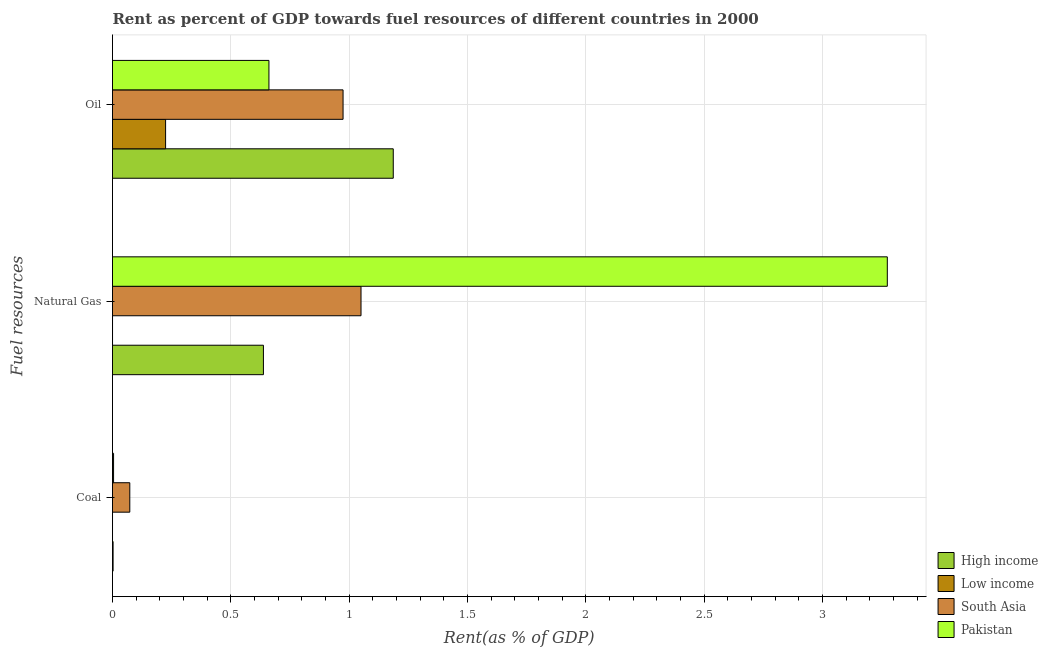How many groups of bars are there?
Your answer should be very brief. 3. Are the number of bars on each tick of the Y-axis equal?
Provide a short and direct response. Yes. How many bars are there on the 1st tick from the top?
Make the answer very short. 4. How many bars are there on the 3rd tick from the bottom?
Provide a succinct answer. 4. What is the label of the 3rd group of bars from the top?
Ensure brevity in your answer.  Coal. What is the rent towards oil in Low income?
Make the answer very short. 0.22. Across all countries, what is the maximum rent towards oil?
Make the answer very short. 1.19. Across all countries, what is the minimum rent towards natural gas?
Offer a very short reply. 0. In which country was the rent towards natural gas minimum?
Ensure brevity in your answer.  Low income. What is the total rent towards natural gas in the graph?
Your response must be concise. 4.96. What is the difference between the rent towards natural gas in Pakistan and that in High income?
Keep it short and to the point. 2.64. What is the difference between the rent towards coal in South Asia and the rent towards oil in Pakistan?
Your response must be concise. -0.59. What is the average rent towards oil per country?
Provide a succinct answer. 0.76. What is the difference between the rent towards coal and rent towards oil in Pakistan?
Offer a very short reply. -0.66. What is the ratio of the rent towards oil in High income to that in Pakistan?
Provide a succinct answer. 1.79. Is the rent towards oil in Pakistan less than that in Low income?
Offer a terse response. No. Is the difference between the rent towards oil in Pakistan and Low income greater than the difference between the rent towards coal in Pakistan and Low income?
Offer a terse response. Yes. What is the difference between the highest and the second highest rent towards coal?
Ensure brevity in your answer.  0.07. What is the difference between the highest and the lowest rent towards natural gas?
Your answer should be compact. 3.27. In how many countries, is the rent towards oil greater than the average rent towards oil taken over all countries?
Provide a succinct answer. 2. Is the sum of the rent towards oil in High income and Low income greater than the maximum rent towards coal across all countries?
Make the answer very short. Yes. What does the 3rd bar from the top in Coal represents?
Your response must be concise. Low income. What does the 3rd bar from the bottom in Oil represents?
Make the answer very short. South Asia. Is it the case that in every country, the sum of the rent towards coal and rent towards natural gas is greater than the rent towards oil?
Provide a short and direct response. No. Are all the bars in the graph horizontal?
Your response must be concise. Yes. Does the graph contain grids?
Make the answer very short. Yes. What is the title of the graph?
Offer a terse response. Rent as percent of GDP towards fuel resources of different countries in 2000. Does "Equatorial Guinea" appear as one of the legend labels in the graph?
Your response must be concise. No. What is the label or title of the X-axis?
Offer a terse response. Rent(as % of GDP). What is the label or title of the Y-axis?
Your response must be concise. Fuel resources. What is the Rent(as % of GDP) of High income in Coal?
Give a very brief answer. 0. What is the Rent(as % of GDP) of Low income in Coal?
Make the answer very short. 3.43081541094935e-5. What is the Rent(as % of GDP) of South Asia in Coal?
Ensure brevity in your answer.  0.07. What is the Rent(as % of GDP) in Pakistan in Coal?
Make the answer very short. 0. What is the Rent(as % of GDP) of High income in Natural Gas?
Your answer should be compact. 0.64. What is the Rent(as % of GDP) of Low income in Natural Gas?
Provide a short and direct response. 0. What is the Rent(as % of GDP) in South Asia in Natural Gas?
Give a very brief answer. 1.05. What is the Rent(as % of GDP) of Pakistan in Natural Gas?
Offer a very short reply. 3.27. What is the Rent(as % of GDP) in High income in Oil?
Your response must be concise. 1.19. What is the Rent(as % of GDP) of Low income in Oil?
Your answer should be very brief. 0.22. What is the Rent(as % of GDP) of South Asia in Oil?
Provide a succinct answer. 0.97. What is the Rent(as % of GDP) of Pakistan in Oil?
Provide a succinct answer. 0.66. Across all Fuel resources, what is the maximum Rent(as % of GDP) of High income?
Provide a succinct answer. 1.19. Across all Fuel resources, what is the maximum Rent(as % of GDP) of Low income?
Offer a terse response. 0.22. Across all Fuel resources, what is the maximum Rent(as % of GDP) in South Asia?
Offer a terse response. 1.05. Across all Fuel resources, what is the maximum Rent(as % of GDP) in Pakistan?
Ensure brevity in your answer.  3.27. Across all Fuel resources, what is the minimum Rent(as % of GDP) of High income?
Keep it short and to the point. 0. Across all Fuel resources, what is the minimum Rent(as % of GDP) of Low income?
Keep it short and to the point. 3.43081541094935e-5. Across all Fuel resources, what is the minimum Rent(as % of GDP) in South Asia?
Give a very brief answer. 0.07. Across all Fuel resources, what is the minimum Rent(as % of GDP) in Pakistan?
Ensure brevity in your answer.  0. What is the total Rent(as % of GDP) in High income in the graph?
Offer a very short reply. 1.83. What is the total Rent(as % of GDP) of Low income in the graph?
Provide a short and direct response. 0.22. What is the total Rent(as % of GDP) of South Asia in the graph?
Your response must be concise. 2.1. What is the total Rent(as % of GDP) in Pakistan in the graph?
Ensure brevity in your answer.  3.94. What is the difference between the Rent(as % of GDP) of High income in Coal and that in Natural Gas?
Your response must be concise. -0.64. What is the difference between the Rent(as % of GDP) in Low income in Coal and that in Natural Gas?
Give a very brief answer. -0. What is the difference between the Rent(as % of GDP) in South Asia in Coal and that in Natural Gas?
Offer a terse response. -0.98. What is the difference between the Rent(as % of GDP) in Pakistan in Coal and that in Natural Gas?
Your answer should be very brief. -3.27. What is the difference between the Rent(as % of GDP) of High income in Coal and that in Oil?
Make the answer very short. -1.18. What is the difference between the Rent(as % of GDP) of Low income in Coal and that in Oil?
Offer a very short reply. -0.22. What is the difference between the Rent(as % of GDP) of South Asia in Coal and that in Oil?
Give a very brief answer. -0.9. What is the difference between the Rent(as % of GDP) in Pakistan in Coal and that in Oil?
Your answer should be compact. -0.66. What is the difference between the Rent(as % of GDP) of High income in Natural Gas and that in Oil?
Give a very brief answer. -0.55. What is the difference between the Rent(as % of GDP) in Low income in Natural Gas and that in Oil?
Provide a succinct answer. -0.22. What is the difference between the Rent(as % of GDP) in South Asia in Natural Gas and that in Oil?
Provide a short and direct response. 0.08. What is the difference between the Rent(as % of GDP) in Pakistan in Natural Gas and that in Oil?
Give a very brief answer. 2.61. What is the difference between the Rent(as % of GDP) in High income in Coal and the Rent(as % of GDP) in Low income in Natural Gas?
Your answer should be compact. 0. What is the difference between the Rent(as % of GDP) of High income in Coal and the Rent(as % of GDP) of South Asia in Natural Gas?
Your answer should be compact. -1.05. What is the difference between the Rent(as % of GDP) of High income in Coal and the Rent(as % of GDP) of Pakistan in Natural Gas?
Make the answer very short. -3.27. What is the difference between the Rent(as % of GDP) in Low income in Coal and the Rent(as % of GDP) in South Asia in Natural Gas?
Give a very brief answer. -1.05. What is the difference between the Rent(as % of GDP) of Low income in Coal and the Rent(as % of GDP) of Pakistan in Natural Gas?
Offer a very short reply. -3.27. What is the difference between the Rent(as % of GDP) in South Asia in Coal and the Rent(as % of GDP) in Pakistan in Natural Gas?
Make the answer very short. -3.2. What is the difference between the Rent(as % of GDP) of High income in Coal and the Rent(as % of GDP) of Low income in Oil?
Your answer should be very brief. -0.22. What is the difference between the Rent(as % of GDP) in High income in Coal and the Rent(as % of GDP) in South Asia in Oil?
Make the answer very short. -0.97. What is the difference between the Rent(as % of GDP) in High income in Coal and the Rent(as % of GDP) in Pakistan in Oil?
Offer a very short reply. -0.66. What is the difference between the Rent(as % of GDP) in Low income in Coal and the Rent(as % of GDP) in South Asia in Oil?
Offer a terse response. -0.97. What is the difference between the Rent(as % of GDP) in Low income in Coal and the Rent(as % of GDP) in Pakistan in Oil?
Your answer should be very brief. -0.66. What is the difference between the Rent(as % of GDP) of South Asia in Coal and the Rent(as % of GDP) of Pakistan in Oil?
Provide a succinct answer. -0.59. What is the difference between the Rent(as % of GDP) of High income in Natural Gas and the Rent(as % of GDP) of Low income in Oil?
Your answer should be very brief. 0.41. What is the difference between the Rent(as % of GDP) of High income in Natural Gas and the Rent(as % of GDP) of South Asia in Oil?
Your response must be concise. -0.34. What is the difference between the Rent(as % of GDP) in High income in Natural Gas and the Rent(as % of GDP) in Pakistan in Oil?
Provide a short and direct response. -0.02. What is the difference between the Rent(as % of GDP) in Low income in Natural Gas and the Rent(as % of GDP) in South Asia in Oil?
Your answer should be very brief. -0.97. What is the difference between the Rent(as % of GDP) in Low income in Natural Gas and the Rent(as % of GDP) in Pakistan in Oil?
Offer a very short reply. -0.66. What is the difference between the Rent(as % of GDP) of South Asia in Natural Gas and the Rent(as % of GDP) of Pakistan in Oil?
Provide a succinct answer. 0.39. What is the average Rent(as % of GDP) of High income per Fuel resources?
Offer a very short reply. 0.61. What is the average Rent(as % of GDP) of Low income per Fuel resources?
Provide a short and direct response. 0.07. What is the average Rent(as % of GDP) in South Asia per Fuel resources?
Give a very brief answer. 0.7. What is the average Rent(as % of GDP) in Pakistan per Fuel resources?
Make the answer very short. 1.31. What is the difference between the Rent(as % of GDP) in High income and Rent(as % of GDP) in Low income in Coal?
Offer a terse response. 0. What is the difference between the Rent(as % of GDP) in High income and Rent(as % of GDP) in South Asia in Coal?
Your response must be concise. -0.07. What is the difference between the Rent(as % of GDP) of High income and Rent(as % of GDP) of Pakistan in Coal?
Offer a terse response. -0. What is the difference between the Rent(as % of GDP) in Low income and Rent(as % of GDP) in South Asia in Coal?
Make the answer very short. -0.07. What is the difference between the Rent(as % of GDP) of Low income and Rent(as % of GDP) of Pakistan in Coal?
Your answer should be very brief. -0. What is the difference between the Rent(as % of GDP) of South Asia and Rent(as % of GDP) of Pakistan in Coal?
Give a very brief answer. 0.07. What is the difference between the Rent(as % of GDP) in High income and Rent(as % of GDP) in Low income in Natural Gas?
Provide a succinct answer. 0.64. What is the difference between the Rent(as % of GDP) of High income and Rent(as % of GDP) of South Asia in Natural Gas?
Ensure brevity in your answer.  -0.41. What is the difference between the Rent(as % of GDP) of High income and Rent(as % of GDP) of Pakistan in Natural Gas?
Your answer should be compact. -2.64. What is the difference between the Rent(as % of GDP) of Low income and Rent(as % of GDP) of South Asia in Natural Gas?
Keep it short and to the point. -1.05. What is the difference between the Rent(as % of GDP) in Low income and Rent(as % of GDP) in Pakistan in Natural Gas?
Keep it short and to the point. -3.27. What is the difference between the Rent(as % of GDP) of South Asia and Rent(as % of GDP) of Pakistan in Natural Gas?
Give a very brief answer. -2.22. What is the difference between the Rent(as % of GDP) in High income and Rent(as % of GDP) in Low income in Oil?
Offer a terse response. 0.96. What is the difference between the Rent(as % of GDP) in High income and Rent(as % of GDP) in South Asia in Oil?
Ensure brevity in your answer.  0.21. What is the difference between the Rent(as % of GDP) of High income and Rent(as % of GDP) of Pakistan in Oil?
Make the answer very short. 0.53. What is the difference between the Rent(as % of GDP) in Low income and Rent(as % of GDP) in South Asia in Oil?
Provide a short and direct response. -0.75. What is the difference between the Rent(as % of GDP) of Low income and Rent(as % of GDP) of Pakistan in Oil?
Your response must be concise. -0.44. What is the difference between the Rent(as % of GDP) in South Asia and Rent(as % of GDP) in Pakistan in Oil?
Keep it short and to the point. 0.31. What is the ratio of the Rent(as % of GDP) in High income in Coal to that in Natural Gas?
Give a very brief answer. 0. What is the ratio of the Rent(as % of GDP) of Low income in Coal to that in Natural Gas?
Provide a short and direct response. 0.23. What is the ratio of the Rent(as % of GDP) of South Asia in Coal to that in Natural Gas?
Your answer should be very brief. 0.07. What is the ratio of the Rent(as % of GDP) in Pakistan in Coal to that in Natural Gas?
Provide a short and direct response. 0. What is the ratio of the Rent(as % of GDP) of High income in Coal to that in Oil?
Your response must be concise. 0. What is the ratio of the Rent(as % of GDP) of Low income in Coal to that in Oil?
Your answer should be very brief. 0. What is the ratio of the Rent(as % of GDP) in South Asia in Coal to that in Oil?
Provide a succinct answer. 0.07. What is the ratio of the Rent(as % of GDP) of Pakistan in Coal to that in Oil?
Your answer should be compact. 0.01. What is the ratio of the Rent(as % of GDP) of High income in Natural Gas to that in Oil?
Provide a succinct answer. 0.54. What is the ratio of the Rent(as % of GDP) of Low income in Natural Gas to that in Oil?
Provide a succinct answer. 0. What is the ratio of the Rent(as % of GDP) in South Asia in Natural Gas to that in Oil?
Your answer should be very brief. 1.08. What is the ratio of the Rent(as % of GDP) in Pakistan in Natural Gas to that in Oil?
Give a very brief answer. 4.95. What is the difference between the highest and the second highest Rent(as % of GDP) in High income?
Make the answer very short. 0.55. What is the difference between the highest and the second highest Rent(as % of GDP) of Low income?
Offer a very short reply. 0.22. What is the difference between the highest and the second highest Rent(as % of GDP) in South Asia?
Give a very brief answer. 0.08. What is the difference between the highest and the second highest Rent(as % of GDP) in Pakistan?
Ensure brevity in your answer.  2.61. What is the difference between the highest and the lowest Rent(as % of GDP) in High income?
Keep it short and to the point. 1.18. What is the difference between the highest and the lowest Rent(as % of GDP) of Low income?
Your answer should be compact. 0.22. What is the difference between the highest and the lowest Rent(as % of GDP) in South Asia?
Offer a terse response. 0.98. What is the difference between the highest and the lowest Rent(as % of GDP) of Pakistan?
Provide a short and direct response. 3.27. 